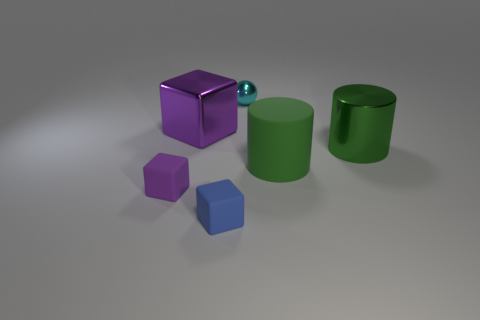Add 3 large shiny cylinders. How many objects exist? 9 Subtract all balls. How many objects are left? 5 Subtract 0 red blocks. How many objects are left? 6 Subtract all cyan blocks. Subtract all rubber objects. How many objects are left? 3 Add 3 small cyan spheres. How many small cyan spheres are left? 4 Add 6 small rubber objects. How many small rubber objects exist? 8 